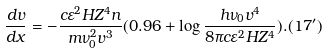Convert formula to latex. <formula><loc_0><loc_0><loc_500><loc_500>\frac { d v } { d x } = - \frac { c \varepsilon ^ { 2 } H Z ^ { 4 } n } { m \nu _ { 0 } ^ { 2 } v ^ { 3 } } ( 0 . 9 6 + \log \frac { h \nu _ { 0 } v ^ { 4 } } { 8 \pi c \varepsilon ^ { 2 } H Z ^ { 4 } } ) . ( 1 7 ^ { \prime } )</formula> 